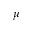Convert formula to latex. <formula><loc_0><loc_0><loc_500><loc_500>\mu</formula> 